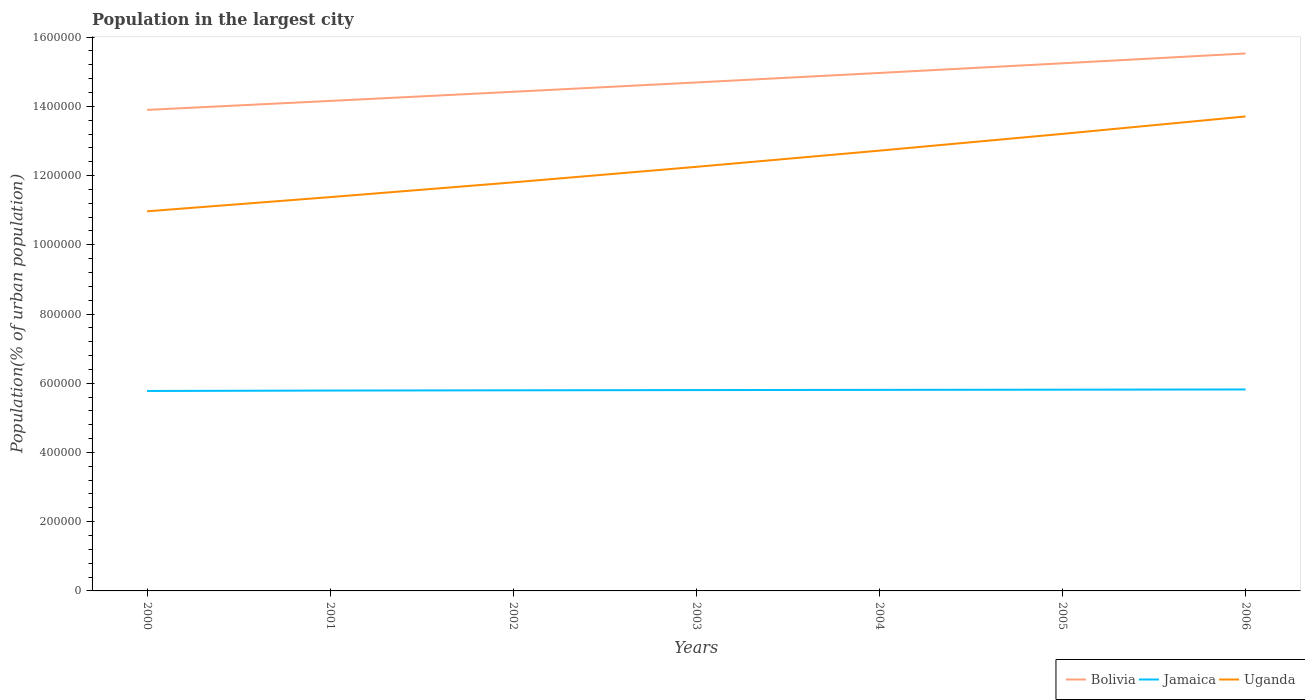Across all years, what is the maximum population in the largest city in Bolivia?
Ensure brevity in your answer.  1.39e+06. What is the total population in the largest city in Jamaica in the graph?
Provide a short and direct response. -2006. What is the difference between the highest and the second highest population in the largest city in Uganda?
Make the answer very short. 2.74e+05. What is the difference between the highest and the lowest population in the largest city in Jamaica?
Your answer should be very brief. 4. Is the population in the largest city in Uganda strictly greater than the population in the largest city in Bolivia over the years?
Ensure brevity in your answer.  Yes. How many years are there in the graph?
Keep it short and to the point. 7. What is the difference between two consecutive major ticks on the Y-axis?
Your answer should be very brief. 2.00e+05. Are the values on the major ticks of Y-axis written in scientific E-notation?
Ensure brevity in your answer.  No. Does the graph contain any zero values?
Offer a terse response. No. Does the graph contain grids?
Your response must be concise. No. What is the title of the graph?
Provide a short and direct response. Population in the largest city. Does "Palau" appear as one of the legend labels in the graph?
Make the answer very short. No. What is the label or title of the X-axis?
Provide a succinct answer. Years. What is the label or title of the Y-axis?
Offer a terse response. Population(% of urban population). What is the Population(% of urban population) in Bolivia in 2000?
Ensure brevity in your answer.  1.39e+06. What is the Population(% of urban population) of Jamaica in 2000?
Your answer should be compact. 5.78e+05. What is the Population(% of urban population) of Uganda in 2000?
Give a very brief answer. 1.10e+06. What is the Population(% of urban population) in Bolivia in 2001?
Offer a very short reply. 1.42e+06. What is the Population(% of urban population) in Jamaica in 2001?
Your response must be concise. 5.79e+05. What is the Population(% of urban population) of Uganda in 2001?
Your answer should be very brief. 1.14e+06. What is the Population(% of urban population) in Bolivia in 2002?
Provide a succinct answer. 1.44e+06. What is the Population(% of urban population) of Jamaica in 2002?
Give a very brief answer. 5.80e+05. What is the Population(% of urban population) in Uganda in 2002?
Your response must be concise. 1.18e+06. What is the Population(% of urban population) in Bolivia in 2003?
Ensure brevity in your answer.  1.47e+06. What is the Population(% of urban population) of Jamaica in 2003?
Keep it short and to the point. 5.80e+05. What is the Population(% of urban population) in Uganda in 2003?
Offer a terse response. 1.23e+06. What is the Population(% of urban population) of Bolivia in 2004?
Your answer should be very brief. 1.50e+06. What is the Population(% of urban population) of Jamaica in 2004?
Your answer should be very brief. 5.81e+05. What is the Population(% of urban population) in Uganda in 2004?
Your answer should be compact. 1.27e+06. What is the Population(% of urban population) of Bolivia in 2005?
Keep it short and to the point. 1.52e+06. What is the Population(% of urban population) in Jamaica in 2005?
Your answer should be compact. 5.81e+05. What is the Population(% of urban population) in Uganda in 2005?
Your answer should be very brief. 1.32e+06. What is the Population(% of urban population) of Bolivia in 2006?
Offer a terse response. 1.55e+06. What is the Population(% of urban population) of Jamaica in 2006?
Your answer should be very brief. 5.82e+05. What is the Population(% of urban population) of Uganda in 2006?
Your answer should be compact. 1.37e+06. Across all years, what is the maximum Population(% of urban population) of Bolivia?
Give a very brief answer. 1.55e+06. Across all years, what is the maximum Population(% of urban population) of Jamaica?
Offer a very short reply. 5.82e+05. Across all years, what is the maximum Population(% of urban population) of Uganda?
Keep it short and to the point. 1.37e+06. Across all years, what is the minimum Population(% of urban population) of Bolivia?
Give a very brief answer. 1.39e+06. Across all years, what is the minimum Population(% of urban population) of Jamaica?
Offer a terse response. 5.78e+05. Across all years, what is the minimum Population(% of urban population) in Uganda?
Provide a short and direct response. 1.10e+06. What is the total Population(% of urban population) in Bolivia in the graph?
Provide a succinct answer. 1.03e+07. What is the total Population(% of urban population) of Jamaica in the graph?
Your answer should be compact. 4.06e+06. What is the total Population(% of urban population) in Uganda in the graph?
Offer a very short reply. 8.60e+06. What is the difference between the Population(% of urban population) in Bolivia in 2000 and that in 2001?
Your answer should be very brief. -2.59e+04. What is the difference between the Population(% of urban population) of Jamaica in 2000 and that in 2001?
Provide a succinct answer. -1283. What is the difference between the Population(% of urban population) in Uganda in 2000 and that in 2001?
Provide a short and direct response. -4.10e+04. What is the difference between the Population(% of urban population) in Bolivia in 2000 and that in 2002?
Keep it short and to the point. -5.23e+04. What is the difference between the Population(% of urban population) of Jamaica in 2000 and that in 2002?
Ensure brevity in your answer.  -2006. What is the difference between the Population(% of urban population) of Uganda in 2000 and that in 2002?
Ensure brevity in your answer.  -8.36e+04. What is the difference between the Population(% of urban population) of Bolivia in 2000 and that in 2003?
Keep it short and to the point. -7.92e+04. What is the difference between the Population(% of urban population) of Jamaica in 2000 and that in 2003?
Provide a succinct answer. -2594. What is the difference between the Population(% of urban population) in Uganda in 2000 and that in 2003?
Offer a very short reply. -1.28e+05. What is the difference between the Population(% of urban population) of Bolivia in 2000 and that in 2004?
Provide a succinct answer. -1.07e+05. What is the difference between the Population(% of urban population) of Jamaica in 2000 and that in 2004?
Give a very brief answer. -3183. What is the difference between the Population(% of urban population) of Uganda in 2000 and that in 2004?
Keep it short and to the point. -1.75e+05. What is the difference between the Population(% of urban population) in Bolivia in 2000 and that in 2005?
Keep it short and to the point. -1.35e+05. What is the difference between the Population(% of urban population) of Jamaica in 2000 and that in 2005?
Your answer should be compact. -3771. What is the difference between the Population(% of urban population) of Uganda in 2000 and that in 2005?
Keep it short and to the point. -2.24e+05. What is the difference between the Population(% of urban population) of Bolivia in 2000 and that in 2006?
Offer a terse response. -1.63e+05. What is the difference between the Population(% of urban population) of Jamaica in 2000 and that in 2006?
Your response must be concise. -4361. What is the difference between the Population(% of urban population) of Uganda in 2000 and that in 2006?
Offer a terse response. -2.74e+05. What is the difference between the Population(% of urban population) in Bolivia in 2001 and that in 2002?
Provide a short and direct response. -2.64e+04. What is the difference between the Population(% of urban population) in Jamaica in 2001 and that in 2002?
Offer a very short reply. -723. What is the difference between the Population(% of urban population) in Uganda in 2001 and that in 2002?
Make the answer very short. -4.26e+04. What is the difference between the Population(% of urban population) of Bolivia in 2001 and that in 2003?
Make the answer very short. -5.33e+04. What is the difference between the Population(% of urban population) in Jamaica in 2001 and that in 2003?
Ensure brevity in your answer.  -1311. What is the difference between the Population(% of urban population) of Uganda in 2001 and that in 2003?
Give a very brief answer. -8.75e+04. What is the difference between the Population(% of urban population) of Bolivia in 2001 and that in 2004?
Keep it short and to the point. -8.08e+04. What is the difference between the Population(% of urban population) of Jamaica in 2001 and that in 2004?
Provide a short and direct response. -1900. What is the difference between the Population(% of urban population) in Uganda in 2001 and that in 2004?
Keep it short and to the point. -1.34e+05. What is the difference between the Population(% of urban population) of Bolivia in 2001 and that in 2005?
Your response must be concise. -1.09e+05. What is the difference between the Population(% of urban population) in Jamaica in 2001 and that in 2005?
Offer a terse response. -2488. What is the difference between the Population(% of urban population) of Uganda in 2001 and that in 2005?
Your response must be concise. -1.83e+05. What is the difference between the Population(% of urban population) in Bolivia in 2001 and that in 2006?
Make the answer very short. -1.37e+05. What is the difference between the Population(% of urban population) of Jamaica in 2001 and that in 2006?
Provide a short and direct response. -3078. What is the difference between the Population(% of urban population) of Uganda in 2001 and that in 2006?
Make the answer very short. -2.33e+05. What is the difference between the Population(% of urban population) in Bolivia in 2002 and that in 2003?
Make the answer very short. -2.69e+04. What is the difference between the Population(% of urban population) of Jamaica in 2002 and that in 2003?
Offer a very short reply. -588. What is the difference between the Population(% of urban population) of Uganda in 2002 and that in 2003?
Offer a very short reply. -4.48e+04. What is the difference between the Population(% of urban population) of Bolivia in 2002 and that in 2004?
Provide a short and direct response. -5.44e+04. What is the difference between the Population(% of urban population) in Jamaica in 2002 and that in 2004?
Give a very brief answer. -1177. What is the difference between the Population(% of urban population) of Uganda in 2002 and that in 2004?
Your answer should be compact. -9.16e+04. What is the difference between the Population(% of urban population) in Bolivia in 2002 and that in 2005?
Your response must be concise. -8.23e+04. What is the difference between the Population(% of urban population) of Jamaica in 2002 and that in 2005?
Offer a terse response. -1765. What is the difference between the Population(% of urban population) of Uganda in 2002 and that in 2005?
Your response must be concise. -1.40e+05. What is the difference between the Population(% of urban population) of Bolivia in 2002 and that in 2006?
Your response must be concise. -1.11e+05. What is the difference between the Population(% of urban population) of Jamaica in 2002 and that in 2006?
Offer a very short reply. -2355. What is the difference between the Population(% of urban population) in Uganda in 2002 and that in 2006?
Give a very brief answer. -1.90e+05. What is the difference between the Population(% of urban population) of Bolivia in 2003 and that in 2004?
Your answer should be compact. -2.75e+04. What is the difference between the Population(% of urban population) in Jamaica in 2003 and that in 2004?
Make the answer very short. -589. What is the difference between the Population(% of urban population) of Uganda in 2003 and that in 2004?
Your response must be concise. -4.68e+04. What is the difference between the Population(% of urban population) in Bolivia in 2003 and that in 2005?
Your answer should be compact. -5.54e+04. What is the difference between the Population(% of urban population) of Jamaica in 2003 and that in 2005?
Your response must be concise. -1177. What is the difference between the Population(% of urban population) of Uganda in 2003 and that in 2005?
Keep it short and to the point. -9.52e+04. What is the difference between the Population(% of urban population) in Bolivia in 2003 and that in 2006?
Keep it short and to the point. -8.38e+04. What is the difference between the Population(% of urban population) of Jamaica in 2003 and that in 2006?
Make the answer very short. -1767. What is the difference between the Population(% of urban population) in Uganda in 2003 and that in 2006?
Provide a short and direct response. -1.46e+05. What is the difference between the Population(% of urban population) of Bolivia in 2004 and that in 2005?
Your answer should be compact. -2.79e+04. What is the difference between the Population(% of urban population) in Jamaica in 2004 and that in 2005?
Offer a terse response. -588. What is the difference between the Population(% of urban population) in Uganda in 2004 and that in 2005?
Keep it short and to the point. -4.84e+04. What is the difference between the Population(% of urban population) of Bolivia in 2004 and that in 2006?
Keep it short and to the point. -5.63e+04. What is the difference between the Population(% of urban population) of Jamaica in 2004 and that in 2006?
Your answer should be compact. -1178. What is the difference between the Population(% of urban population) in Uganda in 2004 and that in 2006?
Keep it short and to the point. -9.88e+04. What is the difference between the Population(% of urban population) in Bolivia in 2005 and that in 2006?
Keep it short and to the point. -2.85e+04. What is the difference between the Population(% of urban population) in Jamaica in 2005 and that in 2006?
Ensure brevity in your answer.  -590. What is the difference between the Population(% of urban population) in Uganda in 2005 and that in 2006?
Keep it short and to the point. -5.04e+04. What is the difference between the Population(% of urban population) of Bolivia in 2000 and the Population(% of urban population) of Jamaica in 2001?
Your response must be concise. 8.11e+05. What is the difference between the Population(% of urban population) in Bolivia in 2000 and the Population(% of urban population) in Uganda in 2001?
Provide a short and direct response. 2.52e+05. What is the difference between the Population(% of urban population) of Jamaica in 2000 and the Population(% of urban population) of Uganda in 2001?
Your answer should be very brief. -5.60e+05. What is the difference between the Population(% of urban population) in Bolivia in 2000 and the Population(% of urban population) in Jamaica in 2002?
Offer a very short reply. 8.10e+05. What is the difference between the Population(% of urban population) in Bolivia in 2000 and the Population(% of urban population) in Uganda in 2002?
Your answer should be compact. 2.09e+05. What is the difference between the Population(% of urban population) of Jamaica in 2000 and the Population(% of urban population) of Uganda in 2002?
Your response must be concise. -6.03e+05. What is the difference between the Population(% of urban population) of Bolivia in 2000 and the Population(% of urban population) of Jamaica in 2003?
Give a very brief answer. 8.09e+05. What is the difference between the Population(% of urban population) in Bolivia in 2000 and the Population(% of urban population) in Uganda in 2003?
Your answer should be very brief. 1.65e+05. What is the difference between the Population(% of urban population) of Jamaica in 2000 and the Population(% of urban population) of Uganda in 2003?
Ensure brevity in your answer.  -6.48e+05. What is the difference between the Population(% of urban population) of Bolivia in 2000 and the Population(% of urban population) of Jamaica in 2004?
Offer a very short reply. 8.09e+05. What is the difference between the Population(% of urban population) of Bolivia in 2000 and the Population(% of urban population) of Uganda in 2004?
Offer a very short reply. 1.18e+05. What is the difference between the Population(% of urban population) of Jamaica in 2000 and the Population(% of urban population) of Uganda in 2004?
Your answer should be compact. -6.94e+05. What is the difference between the Population(% of urban population) of Bolivia in 2000 and the Population(% of urban population) of Jamaica in 2005?
Provide a short and direct response. 8.08e+05. What is the difference between the Population(% of urban population) in Bolivia in 2000 and the Population(% of urban population) in Uganda in 2005?
Provide a succinct answer. 6.93e+04. What is the difference between the Population(% of urban population) of Jamaica in 2000 and the Population(% of urban population) of Uganda in 2005?
Your response must be concise. -7.43e+05. What is the difference between the Population(% of urban population) of Bolivia in 2000 and the Population(% of urban population) of Jamaica in 2006?
Make the answer very short. 8.08e+05. What is the difference between the Population(% of urban population) in Bolivia in 2000 and the Population(% of urban population) in Uganda in 2006?
Offer a terse response. 1.89e+04. What is the difference between the Population(% of urban population) in Jamaica in 2000 and the Population(% of urban population) in Uganda in 2006?
Your answer should be compact. -7.93e+05. What is the difference between the Population(% of urban population) in Bolivia in 2001 and the Population(% of urban population) in Jamaica in 2002?
Keep it short and to the point. 8.36e+05. What is the difference between the Population(% of urban population) of Bolivia in 2001 and the Population(% of urban population) of Uganda in 2002?
Give a very brief answer. 2.35e+05. What is the difference between the Population(% of urban population) in Jamaica in 2001 and the Population(% of urban population) in Uganda in 2002?
Provide a short and direct response. -6.01e+05. What is the difference between the Population(% of urban population) of Bolivia in 2001 and the Population(% of urban population) of Jamaica in 2003?
Ensure brevity in your answer.  8.35e+05. What is the difference between the Population(% of urban population) in Bolivia in 2001 and the Population(% of urban population) in Uganda in 2003?
Your answer should be compact. 1.90e+05. What is the difference between the Population(% of urban population) in Jamaica in 2001 and the Population(% of urban population) in Uganda in 2003?
Offer a very short reply. -6.46e+05. What is the difference between the Population(% of urban population) in Bolivia in 2001 and the Population(% of urban population) in Jamaica in 2004?
Your response must be concise. 8.35e+05. What is the difference between the Population(% of urban population) in Bolivia in 2001 and the Population(% of urban population) in Uganda in 2004?
Offer a very short reply. 1.44e+05. What is the difference between the Population(% of urban population) in Jamaica in 2001 and the Population(% of urban population) in Uganda in 2004?
Your answer should be compact. -6.93e+05. What is the difference between the Population(% of urban population) in Bolivia in 2001 and the Population(% of urban population) in Jamaica in 2005?
Offer a terse response. 8.34e+05. What is the difference between the Population(% of urban population) of Bolivia in 2001 and the Population(% of urban population) of Uganda in 2005?
Provide a succinct answer. 9.52e+04. What is the difference between the Population(% of urban population) of Jamaica in 2001 and the Population(% of urban population) of Uganda in 2005?
Keep it short and to the point. -7.41e+05. What is the difference between the Population(% of urban population) in Bolivia in 2001 and the Population(% of urban population) in Jamaica in 2006?
Offer a very short reply. 8.34e+05. What is the difference between the Population(% of urban population) in Bolivia in 2001 and the Population(% of urban population) in Uganda in 2006?
Keep it short and to the point. 4.48e+04. What is the difference between the Population(% of urban population) of Jamaica in 2001 and the Population(% of urban population) of Uganda in 2006?
Offer a very short reply. -7.92e+05. What is the difference between the Population(% of urban population) of Bolivia in 2002 and the Population(% of urban population) of Jamaica in 2003?
Make the answer very short. 8.62e+05. What is the difference between the Population(% of urban population) in Bolivia in 2002 and the Population(% of urban population) in Uganda in 2003?
Offer a very short reply. 2.17e+05. What is the difference between the Population(% of urban population) of Jamaica in 2002 and the Population(% of urban population) of Uganda in 2003?
Ensure brevity in your answer.  -6.46e+05. What is the difference between the Population(% of urban population) of Bolivia in 2002 and the Population(% of urban population) of Jamaica in 2004?
Ensure brevity in your answer.  8.61e+05. What is the difference between the Population(% of urban population) in Bolivia in 2002 and the Population(% of urban population) in Uganda in 2004?
Offer a terse response. 1.70e+05. What is the difference between the Population(% of urban population) of Jamaica in 2002 and the Population(% of urban population) of Uganda in 2004?
Make the answer very short. -6.92e+05. What is the difference between the Population(% of urban population) of Bolivia in 2002 and the Population(% of urban population) of Jamaica in 2005?
Provide a short and direct response. 8.61e+05. What is the difference between the Population(% of urban population) of Bolivia in 2002 and the Population(% of urban population) of Uganda in 2005?
Ensure brevity in your answer.  1.22e+05. What is the difference between the Population(% of urban population) in Jamaica in 2002 and the Population(% of urban population) in Uganda in 2005?
Ensure brevity in your answer.  -7.41e+05. What is the difference between the Population(% of urban population) in Bolivia in 2002 and the Population(% of urban population) in Jamaica in 2006?
Give a very brief answer. 8.60e+05. What is the difference between the Population(% of urban population) of Bolivia in 2002 and the Population(% of urban population) of Uganda in 2006?
Ensure brevity in your answer.  7.13e+04. What is the difference between the Population(% of urban population) of Jamaica in 2002 and the Population(% of urban population) of Uganda in 2006?
Keep it short and to the point. -7.91e+05. What is the difference between the Population(% of urban population) of Bolivia in 2003 and the Population(% of urban population) of Jamaica in 2004?
Your answer should be very brief. 8.88e+05. What is the difference between the Population(% of urban population) of Bolivia in 2003 and the Population(% of urban population) of Uganda in 2004?
Your response must be concise. 1.97e+05. What is the difference between the Population(% of urban population) in Jamaica in 2003 and the Population(% of urban population) in Uganda in 2004?
Your answer should be very brief. -6.92e+05. What is the difference between the Population(% of urban population) of Bolivia in 2003 and the Population(% of urban population) of Jamaica in 2005?
Your response must be concise. 8.88e+05. What is the difference between the Population(% of urban population) in Bolivia in 2003 and the Population(% of urban population) in Uganda in 2005?
Your answer should be compact. 1.49e+05. What is the difference between the Population(% of urban population) of Jamaica in 2003 and the Population(% of urban population) of Uganda in 2005?
Your answer should be compact. -7.40e+05. What is the difference between the Population(% of urban population) of Bolivia in 2003 and the Population(% of urban population) of Jamaica in 2006?
Your answer should be compact. 8.87e+05. What is the difference between the Population(% of urban population) of Bolivia in 2003 and the Population(% of urban population) of Uganda in 2006?
Provide a short and direct response. 9.82e+04. What is the difference between the Population(% of urban population) in Jamaica in 2003 and the Population(% of urban population) in Uganda in 2006?
Provide a succinct answer. -7.91e+05. What is the difference between the Population(% of urban population) in Bolivia in 2004 and the Population(% of urban population) in Jamaica in 2005?
Make the answer very short. 9.15e+05. What is the difference between the Population(% of urban population) in Bolivia in 2004 and the Population(% of urban population) in Uganda in 2005?
Your answer should be compact. 1.76e+05. What is the difference between the Population(% of urban population) in Jamaica in 2004 and the Population(% of urban population) in Uganda in 2005?
Offer a very short reply. -7.40e+05. What is the difference between the Population(% of urban population) in Bolivia in 2004 and the Population(% of urban population) in Jamaica in 2006?
Offer a very short reply. 9.14e+05. What is the difference between the Population(% of urban population) in Bolivia in 2004 and the Population(% of urban population) in Uganda in 2006?
Provide a succinct answer. 1.26e+05. What is the difference between the Population(% of urban population) in Jamaica in 2004 and the Population(% of urban population) in Uganda in 2006?
Offer a very short reply. -7.90e+05. What is the difference between the Population(% of urban population) in Bolivia in 2005 and the Population(% of urban population) in Jamaica in 2006?
Provide a succinct answer. 9.42e+05. What is the difference between the Population(% of urban population) of Bolivia in 2005 and the Population(% of urban population) of Uganda in 2006?
Provide a short and direct response. 1.54e+05. What is the difference between the Population(% of urban population) in Jamaica in 2005 and the Population(% of urban population) in Uganda in 2006?
Provide a succinct answer. -7.89e+05. What is the average Population(% of urban population) in Bolivia per year?
Provide a succinct answer. 1.47e+06. What is the average Population(% of urban population) in Jamaica per year?
Your answer should be very brief. 5.80e+05. What is the average Population(% of urban population) of Uganda per year?
Your response must be concise. 1.23e+06. In the year 2000, what is the difference between the Population(% of urban population) of Bolivia and Population(% of urban population) of Jamaica?
Provide a succinct answer. 8.12e+05. In the year 2000, what is the difference between the Population(% of urban population) of Bolivia and Population(% of urban population) of Uganda?
Your answer should be very brief. 2.93e+05. In the year 2000, what is the difference between the Population(% of urban population) of Jamaica and Population(% of urban population) of Uganda?
Ensure brevity in your answer.  -5.19e+05. In the year 2001, what is the difference between the Population(% of urban population) of Bolivia and Population(% of urban population) of Jamaica?
Make the answer very short. 8.37e+05. In the year 2001, what is the difference between the Population(% of urban population) of Bolivia and Population(% of urban population) of Uganda?
Keep it short and to the point. 2.78e+05. In the year 2001, what is the difference between the Population(% of urban population) in Jamaica and Population(% of urban population) in Uganda?
Offer a very short reply. -5.59e+05. In the year 2002, what is the difference between the Population(% of urban population) of Bolivia and Population(% of urban population) of Jamaica?
Your answer should be compact. 8.62e+05. In the year 2002, what is the difference between the Population(% of urban population) in Bolivia and Population(% of urban population) in Uganda?
Provide a short and direct response. 2.62e+05. In the year 2002, what is the difference between the Population(% of urban population) in Jamaica and Population(% of urban population) in Uganda?
Keep it short and to the point. -6.01e+05. In the year 2003, what is the difference between the Population(% of urban population) in Bolivia and Population(% of urban population) in Jamaica?
Provide a short and direct response. 8.89e+05. In the year 2003, what is the difference between the Population(% of urban population) in Bolivia and Population(% of urban population) in Uganda?
Offer a terse response. 2.44e+05. In the year 2003, what is the difference between the Population(% of urban population) in Jamaica and Population(% of urban population) in Uganda?
Make the answer very short. -6.45e+05. In the year 2004, what is the difference between the Population(% of urban population) in Bolivia and Population(% of urban population) in Jamaica?
Make the answer very short. 9.16e+05. In the year 2004, what is the difference between the Population(% of urban population) in Bolivia and Population(% of urban population) in Uganda?
Make the answer very short. 2.24e+05. In the year 2004, what is the difference between the Population(% of urban population) of Jamaica and Population(% of urban population) of Uganda?
Provide a succinct answer. -6.91e+05. In the year 2005, what is the difference between the Population(% of urban population) in Bolivia and Population(% of urban population) in Jamaica?
Give a very brief answer. 9.43e+05. In the year 2005, what is the difference between the Population(% of urban population) in Bolivia and Population(% of urban population) in Uganda?
Give a very brief answer. 2.04e+05. In the year 2005, what is the difference between the Population(% of urban population) of Jamaica and Population(% of urban population) of Uganda?
Give a very brief answer. -7.39e+05. In the year 2006, what is the difference between the Population(% of urban population) in Bolivia and Population(% of urban population) in Jamaica?
Provide a short and direct response. 9.71e+05. In the year 2006, what is the difference between the Population(% of urban population) in Bolivia and Population(% of urban population) in Uganda?
Your answer should be compact. 1.82e+05. In the year 2006, what is the difference between the Population(% of urban population) in Jamaica and Population(% of urban population) in Uganda?
Ensure brevity in your answer.  -7.89e+05. What is the ratio of the Population(% of urban population) of Bolivia in 2000 to that in 2001?
Provide a succinct answer. 0.98. What is the ratio of the Population(% of urban population) of Uganda in 2000 to that in 2001?
Your answer should be compact. 0.96. What is the ratio of the Population(% of urban population) in Bolivia in 2000 to that in 2002?
Provide a short and direct response. 0.96. What is the ratio of the Population(% of urban population) in Uganda in 2000 to that in 2002?
Your answer should be compact. 0.93. What is the ratio of the Population(% of urban population) of Bolivia in 2000 to that in 2003?
Keep it short and to the point. 0.95. What is the ratio of the Population(% of urban population) in Jamaica in 2000 to that in 2003?
Give a very brief answer. 1. What is the ratio of the Population(% of urban population) in Uganda in 2000 to that in 2003?
Provide a short and direct response. 0.9. What is the ratio of the Population(% of urban population) of Bolivia in 2000 to that in 2004?
Keep it short and to the point. 0.93. What is the ratio of the Population(% of urban population) in Uganda in 2000 to that in 2004?
Your response must be concise. 0.86. What is the ratio of the Population(% of urban population) of Bolivia in 2000 to that in 2005?
Provide a succinct answer. 0.91. What is the ratio of the Population(% of urban population) in Jamaica in 2000 to that in 2005?
Your answer should be compact. 0.99. What is the ratio of the Population(% of urban population) of Uganda in 2000 to that in 2005?
Your response must be concise. 0.83. What is the ratio of the Population(% of urban population) of Bolivia in 2000 to that in 2006?
Offer a terse response. 0.9. What is the ratio of the Population(% of urban population) of Jamaica in 2000 to that in 2006?
Make the answer very short. 0.99. What is the ratio of the Population(% of urban population) of Uganda in 2000 to that in 2006?
Provide a succinct answer. 0.8. What is the ratio of the Population(% of urban population) in Bolivia in 2001 to that in 2002?
Your answer should be very brief. 0.98. What is the ratio of the Population(% of urban population) of Uganda in 2001 to that in 2002?
Your answer should be very brief. 0.96. What is the ratio of the Population(% of urban population) of Bolivia in 2001 to that in 2003?
Keep it short and to the point. 0.96. What is the ratio of the Population(% of urban population) of Jamaica in 2001 to that in 2003?
Provide a short and direct response. 1. What is the ratio of the Population(% of urban population) in Bolivia in 2001 to that in 2004?
Offer a terse response. 0.95. What is the ratio of the Population(% of urban population) of Uganda in 2001 to that in 2004?
Keep it short and to the point. 0.89. What is the ratio of the Population(% of urban population) in Bolivia in 2001 to that in 2005?
Offer a terse response. 0.93. What is the ratio of the Population(% of urban population) in Uganda in 2001 to that in 2005?
Your response must be concise. 0.86. What is the ratio of the Population(% of urban population) in Bolivia in 2001 to that in 2006?
Provide a short and direct response. 0.91. What is the ratio of the Population(% of urban population) in Jamaica in 2001 to that in 2006?
Your response must be concise. 0.99. What is the ratio of the Population(% of urban population) in Uganda in 2001 to that in 2006?
Offer a very short reply. 0.83. What is the ratio of the Population(% of urban population) of Bolivia in 2002 to that in 2003?
Make the answer very short. 0.98. What is the ratio of the Population(% of urban population) in Jamaica in 2002 to that in 2003?
Make the answer very short. 1. What is the ratio of the Population(% of urban population) of Uganda in 2002 to that in 2003?
Your response must be concise. 0.96. What is the ratio of the Population(% of urban population) of Bolivia in 2002 to that in 2004?
Ensure brevity in your answer.  0.96. What is the ratio of the Population(% of urban population) in Uganda in 2002 to that in 2004?
Ensure brevity in your answer.  0.93. What is the ratio of the Population(% of urban population) of Bolivia in 2002 to that in 2005?
Provide a short and direct response. 0.95. What is the ratio of the Population(% of urban population) of Uganda in 2002 to that in 2005?
Provide a succinct answer. 0.89. What is the ratio of the Population(% of urban population) in Bolivia in 2002 to that in 2006?
Your answer should be compact. 0.93. What is the ratio of the Population(% of urban population) of Uganda in 2002 to that in 2006?
Make the answer very short. 0.86. What is the ratio of the Population(% of urban population) of Bolivia in 2003 to that in 2004?
Offer a very short reply. 0.98. What is the ratio of the Population(% of urban population) in Uganda in 2003 to that in 2004?
Your answer should be compact. 0.96. What is the ratio of the Population(% of urban population) in Bolivia in 2003 to that in 2005?
Provide a succinct answer. 0.96. What is the ratio of the Population(% of urban population) of Jamaica in 2003 to that in 2005?
Give a very brief answer. 1. What is the ratio of the Population(% of urban population) in Uganda in 2003 to that in 2005?
Offer a terse response. 0.93. What is the ratio of the Population(% of urban population) of Bolivia in 2003 to that in 2006?
Provide a succinct answer. 0.95. What is the ratio of the Population(% of urban population) in Uganda in 2003 to that in 2006?
Your answer should be very brief. 0.89. What is the ratio of the Population(% of urban population) of Bolivia in 2004 to that in 2005?
Keep it short and to the point. 0.98. What is the ratio of the Population(% of urban population) of Uganda in 2004 to that in 2005?
Ensure brevity in your answer.  0.96. What is the ratio of the Population(% of urban population) in Bolivia in 2004 to that in 2006?
Give a very brief answer. 0.96. What is the ratio of the Population(% of urban population) in Uganda in 2004 to that in 2006?
Keep it short and to the point. 0.93. What is the ratio of the Population(% of urban population) in Bolivia in 2005 to that in 2006?
Your response must be concise. 0.98. What is the ratio of the Population(% of urban population) in Uganda in 2005 to that in 2006?
Keep it short and to the point. 0.96. What is the difference between the highest and the second highest Population(% of urban population) in Bolivia?
Your response must be concise. 2.85e+04. What is the difference between the highest and the second highest Population(% of urban population) of Jamaica?
Give a very brief answer. 590. What is the difference between the highest and the second highest Population(% of urban population) of Uganda?
Offer a terse response. 5.04e+04. What is the difference between the highest and the lowest Population(% of urban population) of Bolivia?
Offer a very short reply. 1.63e+05. What is the difference between the highest and the lowest Population(% of urban population) in Jamaica?
Make the answer very short. 4361. What is the difference between the highest and the lowest Population(% of urban population) in Uganda?
Provide a succinct answer. 2.74e+05. 